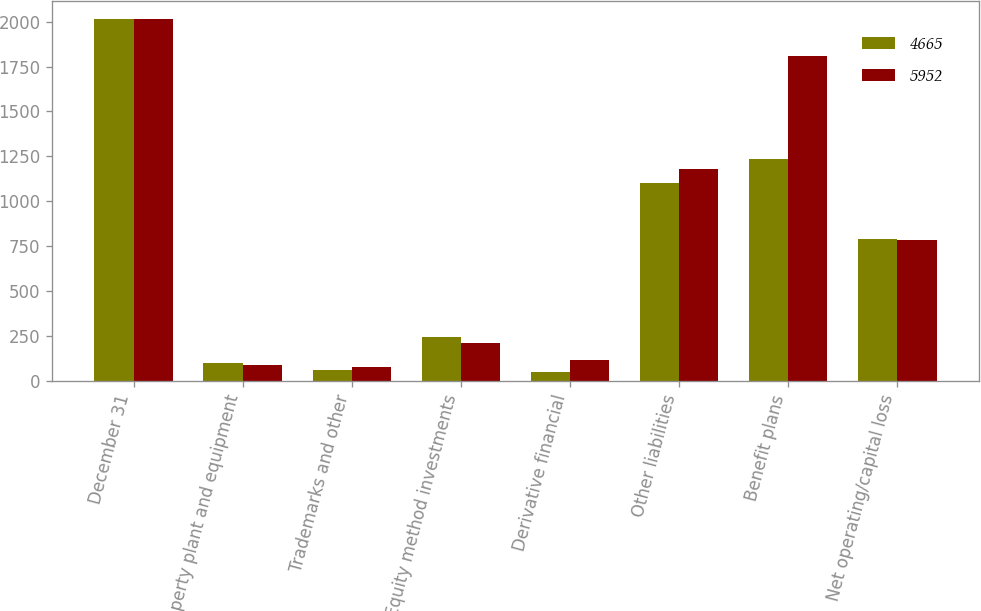<chart> <loc_0><loc_0><loc_500><loc_500><stacked_bar_chart><ecel><fcel>December 31<fcel>Property plant and equipment<fcel>Trademarks and other<fcel>Equity method investments<fcel>Derivative financial<fcel>Other liabilities<fcel>Benefit plans<fcel>Net operating/capital loss<nl><fcel>4665<fcel>2013<fcel>102<fcel>63<fcel>243<fcel>50<fcel>1102<fcel>1237<fcel>790<nl><fcel>5952<fcel>2012<fcel>89<fcel>77<fcel>209<fcel>116<fcel>1178<fcel>1808<fcel>782<nl></chart> 